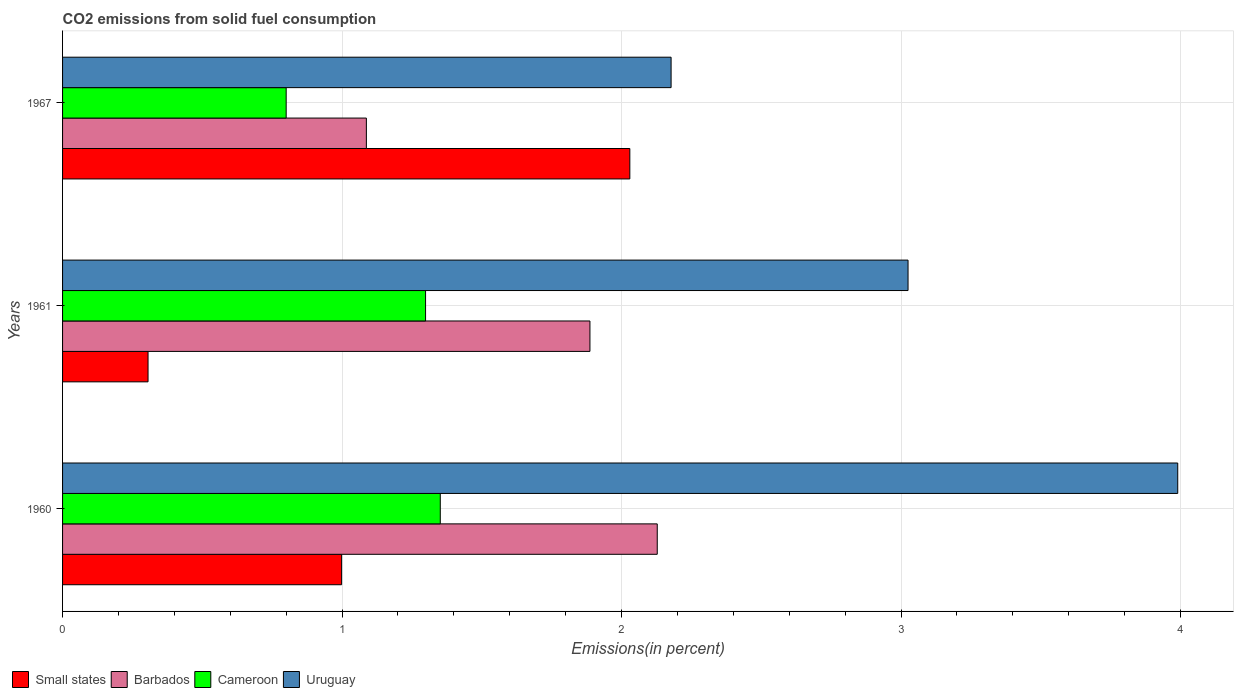How many groups of bars are there?
Keep it short and to the point. 3. Are the number of bars on each tick of the Y-axis equal?
Your response must be concise. Yes. What is the total CO2 emitted in Cameroon in 1960?
Your answer should be compact. 1.35. Across all years, what is the maximum total CO2 emitted in Small states?
Make the answer very short. 2.03. Across all years, what is the minimum total CO2 emitted in Small states?
Give a very brief answer. 0.31. In which year was the total CO2 emitted in Small states maximum?
Offer a very short reply. 1967. In which year was the total CO2 emitted in Uruguay minimum?
Your answer should be very brief. 1967. What is the total total CO2 emitted in Barbados in the graph?
Offer a very short reply. 5.1. What is the difference between the total CO2 emitted in Cameroon in 1960 and that in 1967?
Your answer should be compact. 0.55. What is the difference between the total CO2 emitted in Uruguay in 1967 and the total CO2 emitted in Cameroon in 1960?
Make the answer very short. 0.83. What is the average total CO2 emitted in Uruguay per year?
Give a very brief answer. 3.06. In the year 1967, what is the difference between the total CO2 emitted in Small states and total CO2 emitted in Barbados?
Keep it short and to the point. 0.94. In how many years, is the total CO2 emitted in Cameroon greater than 3.2 %?
Provide a short and direct response. 0. What is the ratio of the total CO2 emitted in Uruguay in 1960 to that in 1967?
Your response must be concise. 1.83. Is the total CO2 emitted in Uruguay in 1960 less than that in 1961?
Ensure brevity in your answer.  No. Is the difference between the total CO2 emitted in Small states in 1960 and 1961 greater than the difference between the total CO2 emitted in Barbados in 1960 and 1961?
Keep it short and to the point. Yes. What is the difference between the highest and the second highest total CO2 emitted in Small states?
Make the answer very short. 1.03. What is the difference between the highest and the lowest total CO2 emitted in Barbados?
Ensure brevity in your answer.  1.04. Is the sum of the total CO2 emitted in Barbados in 1960 and 1961 greater than the maximum total CO2 emitted in Small states across all years?
Provide a succinct answer. Yes. Is it the case that in every year, the sum of the total CO2 emitted in Uruguay and total CO2 emitted in Barbados is greater than the sum of total CO2 emitted in Small states and total CO2 emitted in Cameroon?
Offer a very short reply. No. What does the 3rd bar from the top in 1961 represents?
Ensure brevity in your answer.  Barbados. What does the 4th bar from the bottom in 1967 represents?
Give a very brief answer. Uruguay. How many bars are there?
Ensure brevity in your answer.  12. Does the graph contain grids?
Ensure brevity in your answer.  Yes. What is the title of the graph?
Offer a very short reply. CO2 emissions from solid fuel consumption. What is the label or title of the X-axis?
Give a very brief answer. Emissions(in percent). What is the Emissions(in percent) of Small states in 1960?
Provide a short and direct response. 1. What is the Emissions(in percent) in Barbados in 1960?
Offer a terse response. 2.13. What is the Emissions(in percent) in Cameroon in 1960?
Give a very brief answer. 1.35. What is the Emissions(in percent) in Uruguay in 1960?
Keep it short and to the point. 3.99. What is the Emissions(in percent) in Small states in 1961?
Make the answer very short. 0.31. What is the Emissions(in percent) of Barbados in 1961?
Provide a succinct answer. 1.89. What is the Emissions(in percent) of Cameroon in 1961?
Provide a short and direct response. 1.3. What is the Emissions(in percent) of Uruguay in 1961?
Give a very brief answer. 3.02. What is the Emissions(in percent) of Small states in 1967?
Keep it short and to the point. 2.03. What is the Emissions(in percent) in Barbados in 1967?
Your response must be concise. 1.09. What is the Emissions(in percent) of Uruguay in 1967?
Provide a succinct answer. 2.18. Across all years, what is the maximum Emissions(in percent) of Small states?
Offer a terse response. 2.03. Across all years, what is the maximum Emissions(in percent) of Barbados?
Your response must be concise. 2.13. Across all years, what is the maximum Emissions(in percent) in Cameroon?
Offer a very short reply. 1.35. Across all years, what is the maximum Emissions(in percent) in Uruguay?
Make the answer very short. 3.99. Across all years, what is the minimum Emissions(in percent) in Small states?
Keep it short and to the point. 0.31. Across all years, what is the minimum Emissions(in percent) in Barbados?
Provide a succinct answer. 1.09. Across all years, what is the minimum Emissions(in percent) in Cameroon?
Your answer should be very brief. 0.8. Across all years, what is the minimum Emissions(in percent) of Uruguay?
Your answer should be very brief. 2.18. What is the total Emissions(in percent) in Small states in the graph?
Your answer should be very brief. 3.33. What is the total Emissions(in percent) in Barbados in the graph?
Ensure brevity in your answer.  5.1. What is the total Emissions(in percent) of Cameroon in the graph?
Your response must be concise. 3.45. What is the total Emissions(in percent) in Uruguay in the graph?
Your answer should be very brief. 9.19. What is the difference between the Emissions(in percent) in Small states in 1960 and that in 1961?
Provide a succinct answer. 0.69. What is the difference between the Emissions(in percent) in Barbados in 1960 and that in 1961?
Provide a succinct answer. 0.24. What is the difference between the Emissions(in percent) in Cameroon in 1960 and that in 1961?
Offer a terse response. 0.05. What is the difference between the Emissions(in percent) of Uruguay in 1960 and that in 1961?
Offer a very short reply. 0.96. What is the difference between the Emissions(in percent) of Small states in 1960 and that in 1967?
Provide a succinct answer. -1.03. What is the difference between the Emissions(in percent) of Barbados in 1960 and that in 1967?
Offer a very short reply. 1.04. What is the difference between the Emissions(in percent) of Cameroon in 1960 and that in 1967?
Ensure brevity in your answer.  0.55. What is the difference between the Emissions(in percent) in Uruguay in 1960 and that in 1967?
Your answer should be compact. 1.81. What is the difference between the Emissions(in percent) of Small states in 1961 and that in 1967?
Your answer should be very brief. -1.72. What is the difference between the Emissions(in percent) of Barbados in 1961 and that in 1967?
Provide a succinct answer. 0.8. What is the difference between the Emissions(in percent) in Cameroon in 1961 and that in 1967?
Provide a short and direct response. 0.5. What is the difference between the Emissions(in percent) of Uruguay in 1961 and that in 1967?
Your answer should be very brief. 0.85. What is the difference between the Emissions(in percent) in Small states in 1960 and the Emissions(in percent) in Barbados in 1961?
Your answer should be compact. -0.89. What is the difference between the Emissions(in percent) of Small states in 1960 and the Emissions(in percent) of Cameroon in 1961?
Your response must be concise. -0.3. What is the difference between the Emissions(in percent) in Small states in 1960 and the Emissions(in percent) in Uruguay in 1961?
Offer a very short reply. -2.03. What is the difference between the Emissions(in percent) in Barbados in 1960 and the Emissions(in percent) in Cameroon in 1961?
Make the answer very short. 0.83. What is the difference between the Emissions(in percent) in Barbados in 1960 and the Emissions(in percent) in Uruguay in 1961?
Keep it short and to the point. -0.9. What is the difference between the Emissions(in percent) in Cameroon in 1960 and the Emissions(in percent) in Uruguay in 1961?
Make the answer very short. -1.67. What is the difference between the Emissions(in percent) in Small states in 1960 and the Emissions(in percent) in Barbados in 1967?
Make the answer very short. -0.09. What is the difference between the Emissions(in percent) in Small states in 1960 and the Emissions(in percent) in Cameroon in 1967?
Offer a very short reply. 0.2. What is the difference between the Emissions(in percent) in Small states in 1960 and the Emissions(in percent) in Uruguay in 1967?
Offer a terse response. -1.18. What is the difference between the Emissions(in percent) in Barbados in 1960 and the Emissions(in percent) in Cameroon in 1967?
Keep it short and to the point. 1.33. What is the difference between the Emissions(in percent) of Barbados in 1960 and the Emissions(in percent) of Uruguay in 1967?
Your response must be concise. -0.05. What is the difference between the Emissions(in percent) in Cameroon in 1960 and the Emissions(in percent) in Uruguay in 1967?
Offer a very short reply. -0.83. What is the difference between the Emissions(in percent) of Small states in 1961 and the Emissions(in percent) of Barbados in 1967?
Make the answer very short. -0.78. What is the difference between the Emissions(in percent) in Small states in 1961 and the Emissions(in percent) in Cameroon in 1967?
Provide a short and direct response. -0.49. What is the difference between the Emissions(in percent) in Small states in 1961 and the Emissions(in percent) in Uruguay in 1967?
Ensure brevity in your answer.  -1.87. What is the difference between the Emissions(in percent) in Barbados in 1961 and the Emissions(in percent) in Cameroon in 1967?
Offer a terse response. 1.09. What is the difference between the Emissions(in percent) in Barbados in 1961 and the Emissions(in percent) in Uruguay in 1967?
Your response must be concise. -0.29. What is the difference between the Emissions(in percent) in Cameroon in 1961 and the Emissions(in percent) in Uruguay in 1967?
Make the answer very short. -0.88. What is the average Emissions(in percent) in Small states per year?
Provide a short and direct response. 1.11. What is the average Emissions(in percent) of Barbados per year?
Make the answer very short. 1.7. What is the average Emissions(in percent) in Cameroon per year?
Provide a succinct answer. 1.15. What is the average Emissions(in percent) of Uruguay per year?
Give a very brief answer. 3.06. In the year 1960, what is the difference between the Emissions(in percent) in Small states and Emissions(in percent) in Barbados?
Your response must be concise. -1.13. In the year 1960, what is the difference between the Emissions(in percent) of Small states and Emissions(in percent) of Cameroon?
Provide a succinct answer. -0.35. In the year 1960, what is the difference between the Emissions(in percent) of Small states and Emissions(in percent) of Uruguay?
Provide a short and direct response. -2.99. In the year 1960, what is the difference between the Emissions(in percent) in Barbados and Emissions(in percent) in Cameroon?
Ensure brevity in your answer.  0.78. In the year 1960, what is the difference between the Emissions(in percent) in Barbados and Emissions(in percent) in Uruguay?
Provide a short and direct response. -1.86. In the year 1960, what is the difference between the Emissions(in percent) of Cameroon and Emissions(in percent) of Uruguay?
Your answer should be compact. -2.64. In the year 1961, what is the difference between the Emissions(in percent) in Small states and Emissions(in percent) in Barbados?
Provide a short and direct response. -1.58. In the year 1961, what is the difference between the Emissions(in percent) in Small states and Emissions(in percent) in Cameroon?
Your response must be concise. -0.99. In the year 1961, what is the difference between the Emissions(in percent) in Small states and Emissions(in percent) in Uruguay?
Offer a very short reply. -2.72. In the year 1961, what is the difference between the Emissions(in percent) in Barbados and Emissions(in percent) in Cameroon?
Ensure brevity in your answer.  0.59. In the year 1961, what is the difference between the Emissions(in percent) of Barbados and Emissions(in percent) of Uruguay?
Your response must be concise. -1.14. In the year 1961, what is the difference between the Emissions(in percent) of Cameroon and Emissions(in percent) of Uruguay?
Make the answer very short. -1.73. In the year 1967, what is the difference between the Emissions(in percent) in Small states and Emissions(in percent) in Barbados?
Give a very brief answer. 0.94. In the year 1967, what is the difference between the Emissions(in percent) in Small states and Emissions(in percent) in Cameroon?
Provide a short and direct response. 1.23. In the year 1967, what is the difference between the Emissions(in percent) in Small states and Emissions(in percent) in Uruguay?
Offer a terse response. -0.15. In the year 1967, what is the difference between the Emissions(in percent) in Barbados and Emissions(in percent) in Cameroon?
Keep it short and to the point. 0.29. In the year 1967, what is the difference between the Emissions(in percent) of Barbados and Emissions(in percent) of Uruguay?
Keep it short and to the point. -1.09. In the year 1967, what is the difference between the Emissions(in percent) in Cameroon and Emissions(in percent) in Uruguay?
Your answer should be very brief. -1.38. What is the ratio of the Emissions(in percent) of Small states in 1960 to that in 1961?
Make the answer very short. 3.26. What is the ratio of the Emissions(in percent) in Barbados in 1960 to that in 1961?
Give a very brief answer. 1.13. What is the ratio of the Emissions(in percent) in Cameroon in 1960 to that in 1961?
Provide a short and direct response. 1.04. What is the ratio of the Emissions(in percent) of Uruguay in 1960 to that in 1961?
Your response must be concise. 1.32. What is the ratio of the Emissions(in percent) in Small states in 1960 to that in 1967?
Provide a succinct answer. 0.49. What is the ratio of the Emissions(in percent) in Barbados in 1960 to that in 1967?
Offer a terse response. 1.96. What is the ratio of the Emissions(in percent) of Cameroon in 1960 to that in 1967?
Give a very brief answer. 1.69. What is the ratio of the Emissions(in percent) of Uruguay in 1960 to that in 1967?
Your answer should be very brief. 1.83. What is the ratio of the Emissions(in percent) in Small states in 1961 to that in 1967?
Offer a terse response. 0.15. What is the ratio of the Emissions(in percent) of Barbados in 1961 to that in 1967?
Ensure brevity in your answer.  1.74. What is the ratio of the Emissions(in percent) of Cameroon in 1961 to that in 1967?
Offer a terse response. 1.62. What is the ratio of the Emissions(in percent) of Uruguay in 1961 to that in 1967?
Provide a short and direct response. 1.39. What is the difference between the highest and the second highest Emissions(in percent) of Small states?
Make the answer very short. 1.03. What is the difference between the highest and the second highest Emissions(in percent) in Barbados?
Offer a very short reply. 0.24. What is the difference between the highest and the second highest Emissions(in percent) in Cameroon?
Offer a very short reply. 0.05. What is the difference between the highest and the second highest Emissions(in percent) of Uruguay?
Your response must be concise. 0.96. What is the difference between the highest and the lowest Emissions(in percent) in Small states?
Offer a terse response. 1.72. What is the difference between the highest and the lowest Emissions(in percent) of Barbados?
Offer a terse response. 1.04. What is the difference between the highest and the lowest Emissions(in percent) of Cameroon?
Keep it short and to the point. 0.55. What is the difference between the highest and the lowest Emissions(in percent) of Uruguay?
Make the answer very short. 1.81. 